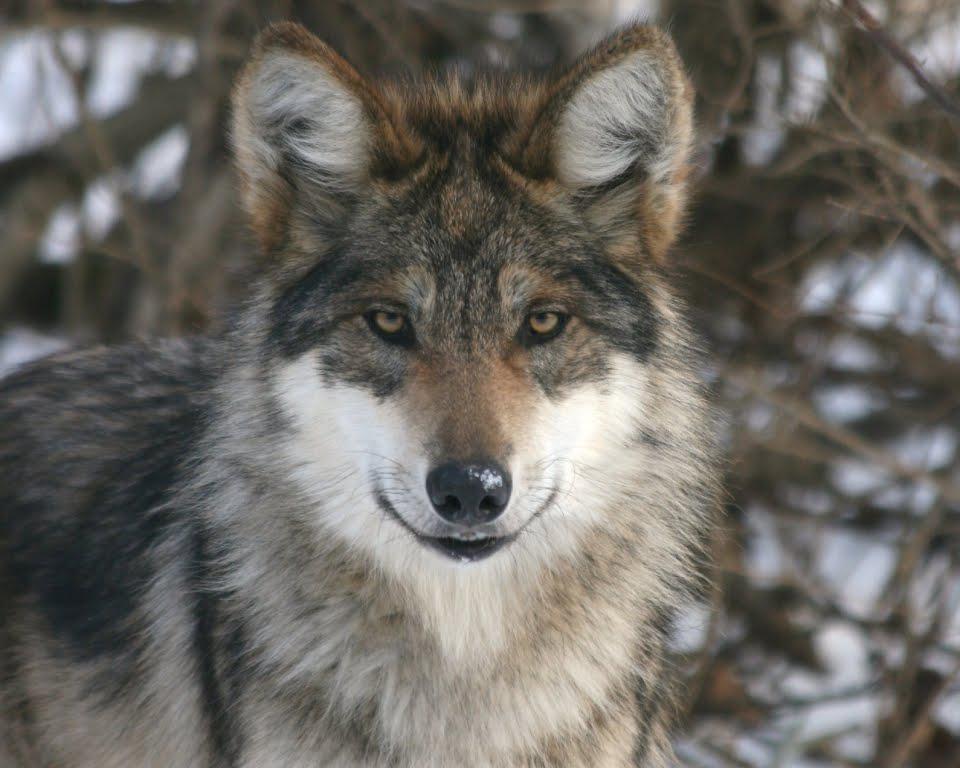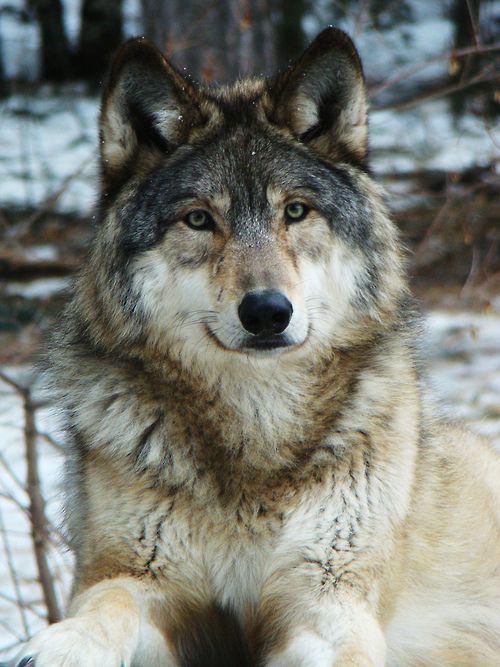The first image is the image on the left, the second image is the image on the right. For the images displayed, is the sentence "A camera-facing wolf has fangs bared in a fierce expression." factually correct? Answer yes or no. No. The first image is the image on the left, the second image is the image on the right. For the images shown, is this caption "There is at least two wolves in the left image." true? Answer yes or no. No. 